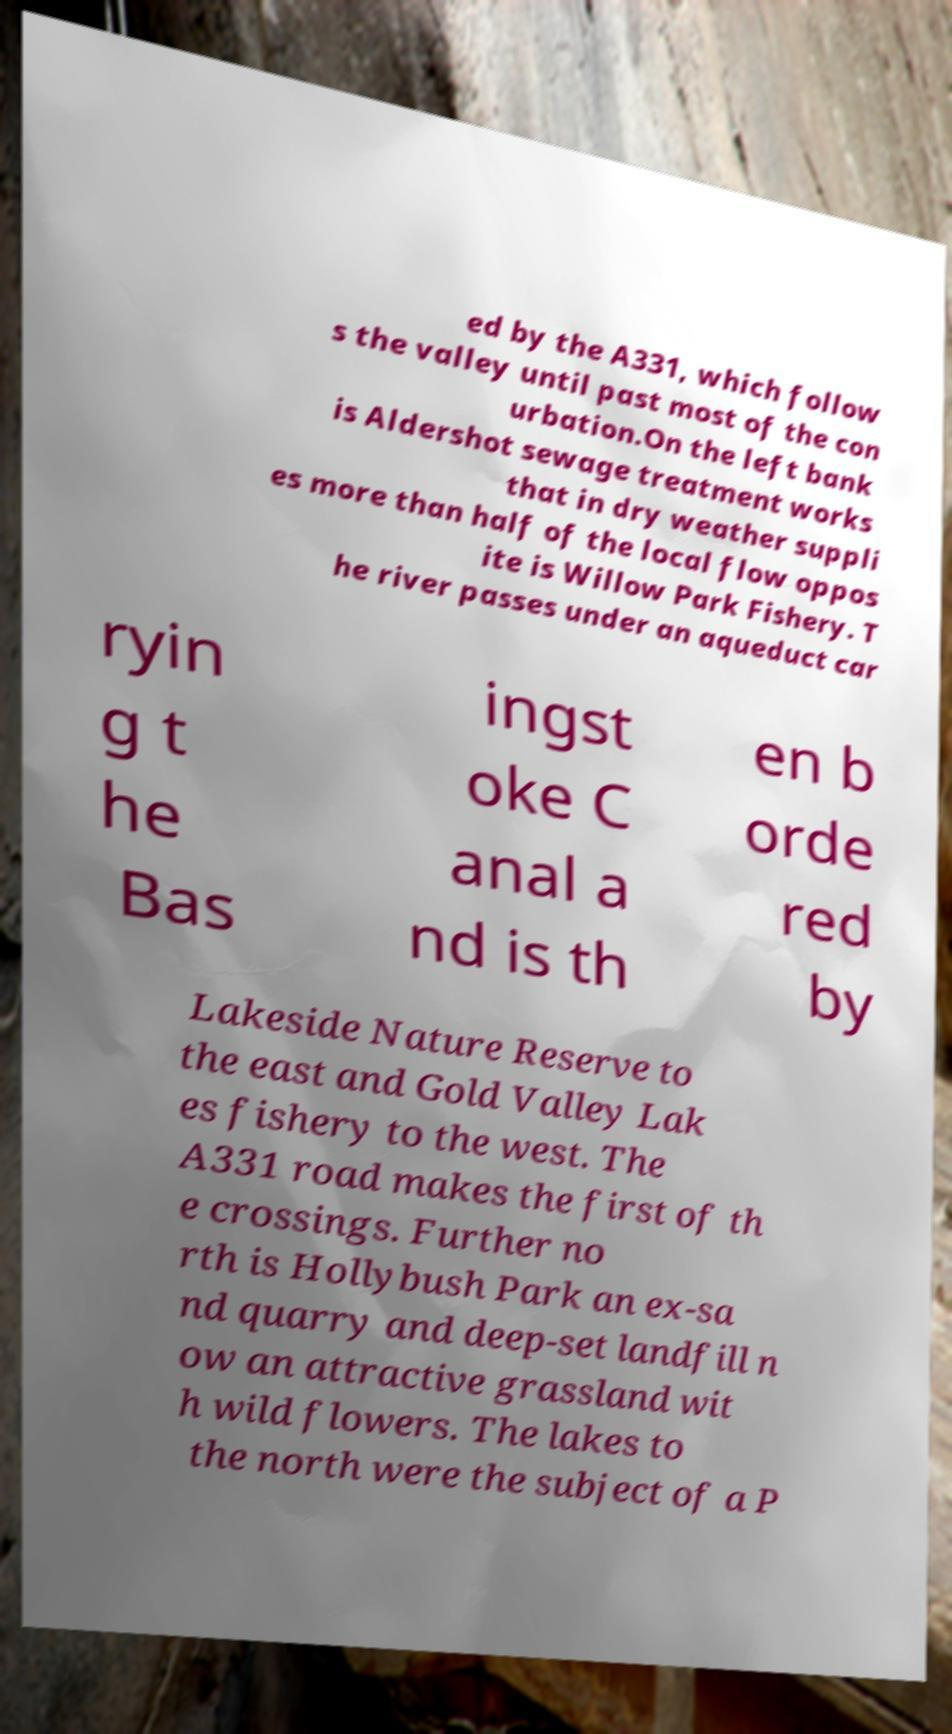Could you assist in decoding the text presented in this image and type it out clearly? ed by the A331, which follow s the valley until past most of the con urbation.On the left bank is Aldershot sewage treatment works that in dry weather suppli es more than half of the local flow oppos ite is Willow Park Fishery. T he river passes under an aqueduct car ryin g t he Bas ingst oke C anal a nd is th en b orde red by Lakeside Nature Reserve to the east and Gold Valley Lak es fishery to the west. The A331 road makes the first of th e crossings. Further no rth is Hollybush Park an ex-sa nd quarry and deep-set landfill n ow an attractive grassland wit h wild flowers. The lakes to the north were the subject of a P 